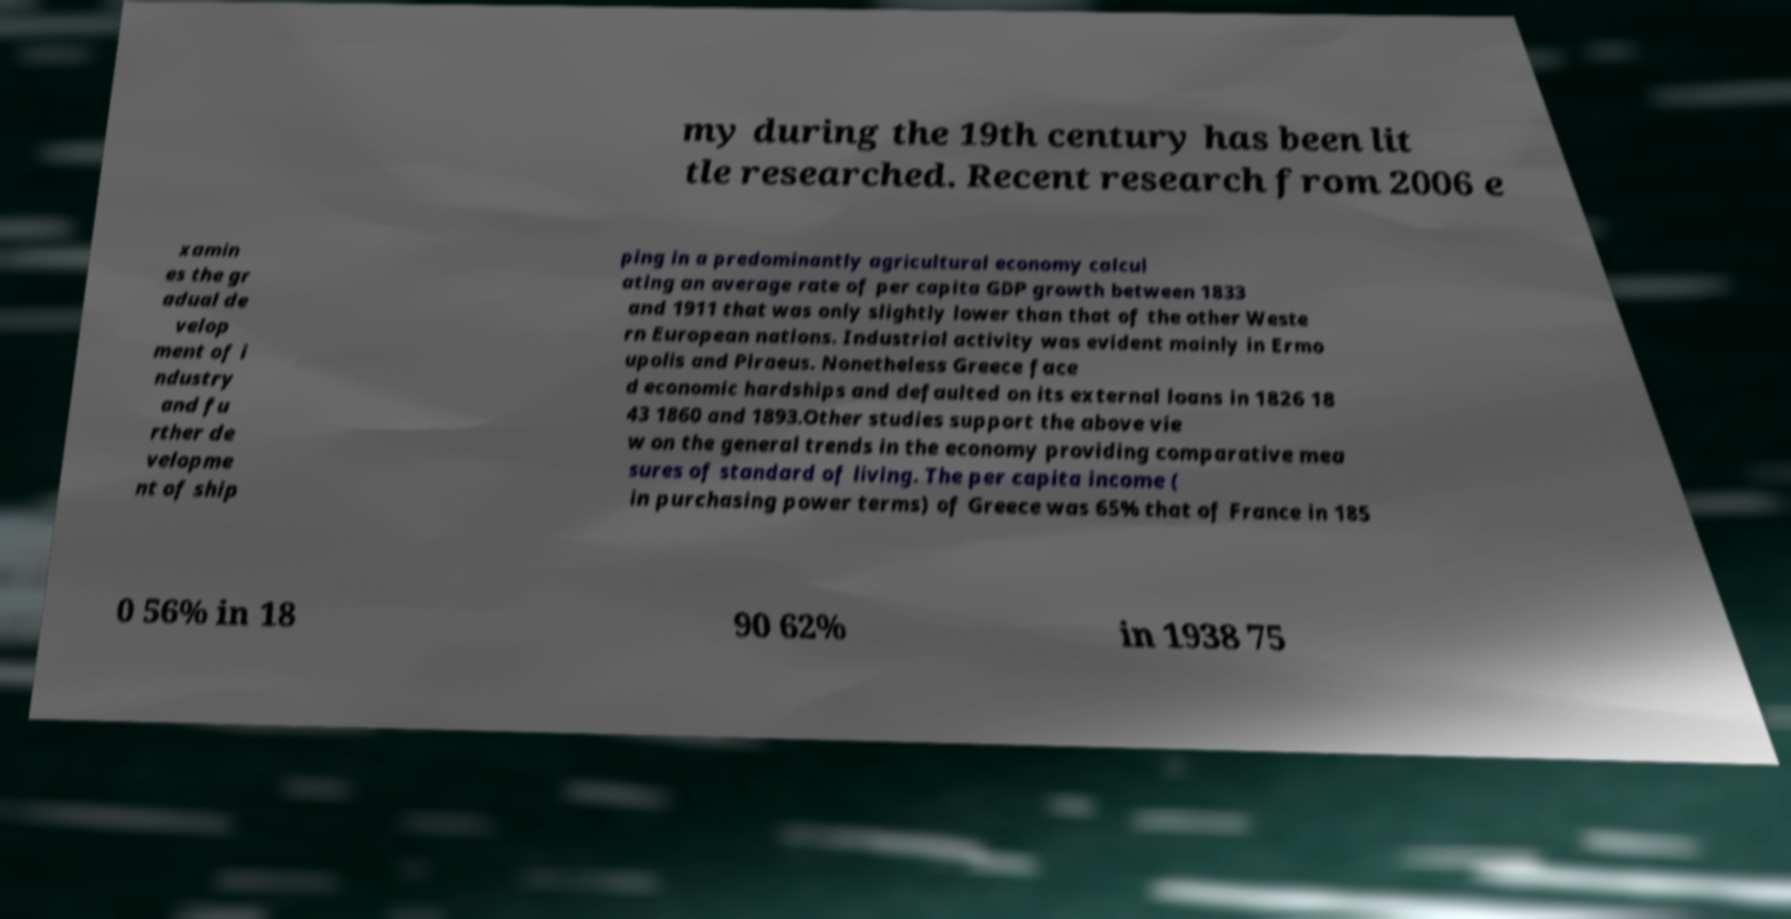Please read and relay the text visible in this image. What does it say? my during the 19th century has been lit tle researched. Recent research from 2006 e xamin es the gr adual de velop ment of i ndustry and fu rther de velopme nt of ship ping in a predominantly agricultural economy calcul ating an average rate of per capita GDP growth between 1833 and 1911 that was only slightly lower than that of the other Weste rn European nations. Industrial activity was evident mainly in Ermo upolis and Piraeus. Nonetheless Greece face d economic hardships and defaulted on its external loans in 1826 18 43 1860 and 1893.Other studies support the above vie w on the general trends in the economy providing comparative mea sures of standard of living. The per capita income ( in purchasing power terms) of Greece was 65% that of France in 185 0 56% in 18 90 62% in 1938 75 